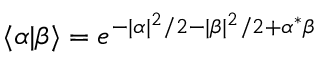<formula> <loc_0><loc_0><loc_500><loc_500>\langle \alpha | \beta \rangle = e ^ { - | \alpha | ^ { 2 } / 2 - | \beta | ^ { 2 } / 2 + \alpha ^ { * } \beta }</formula> 